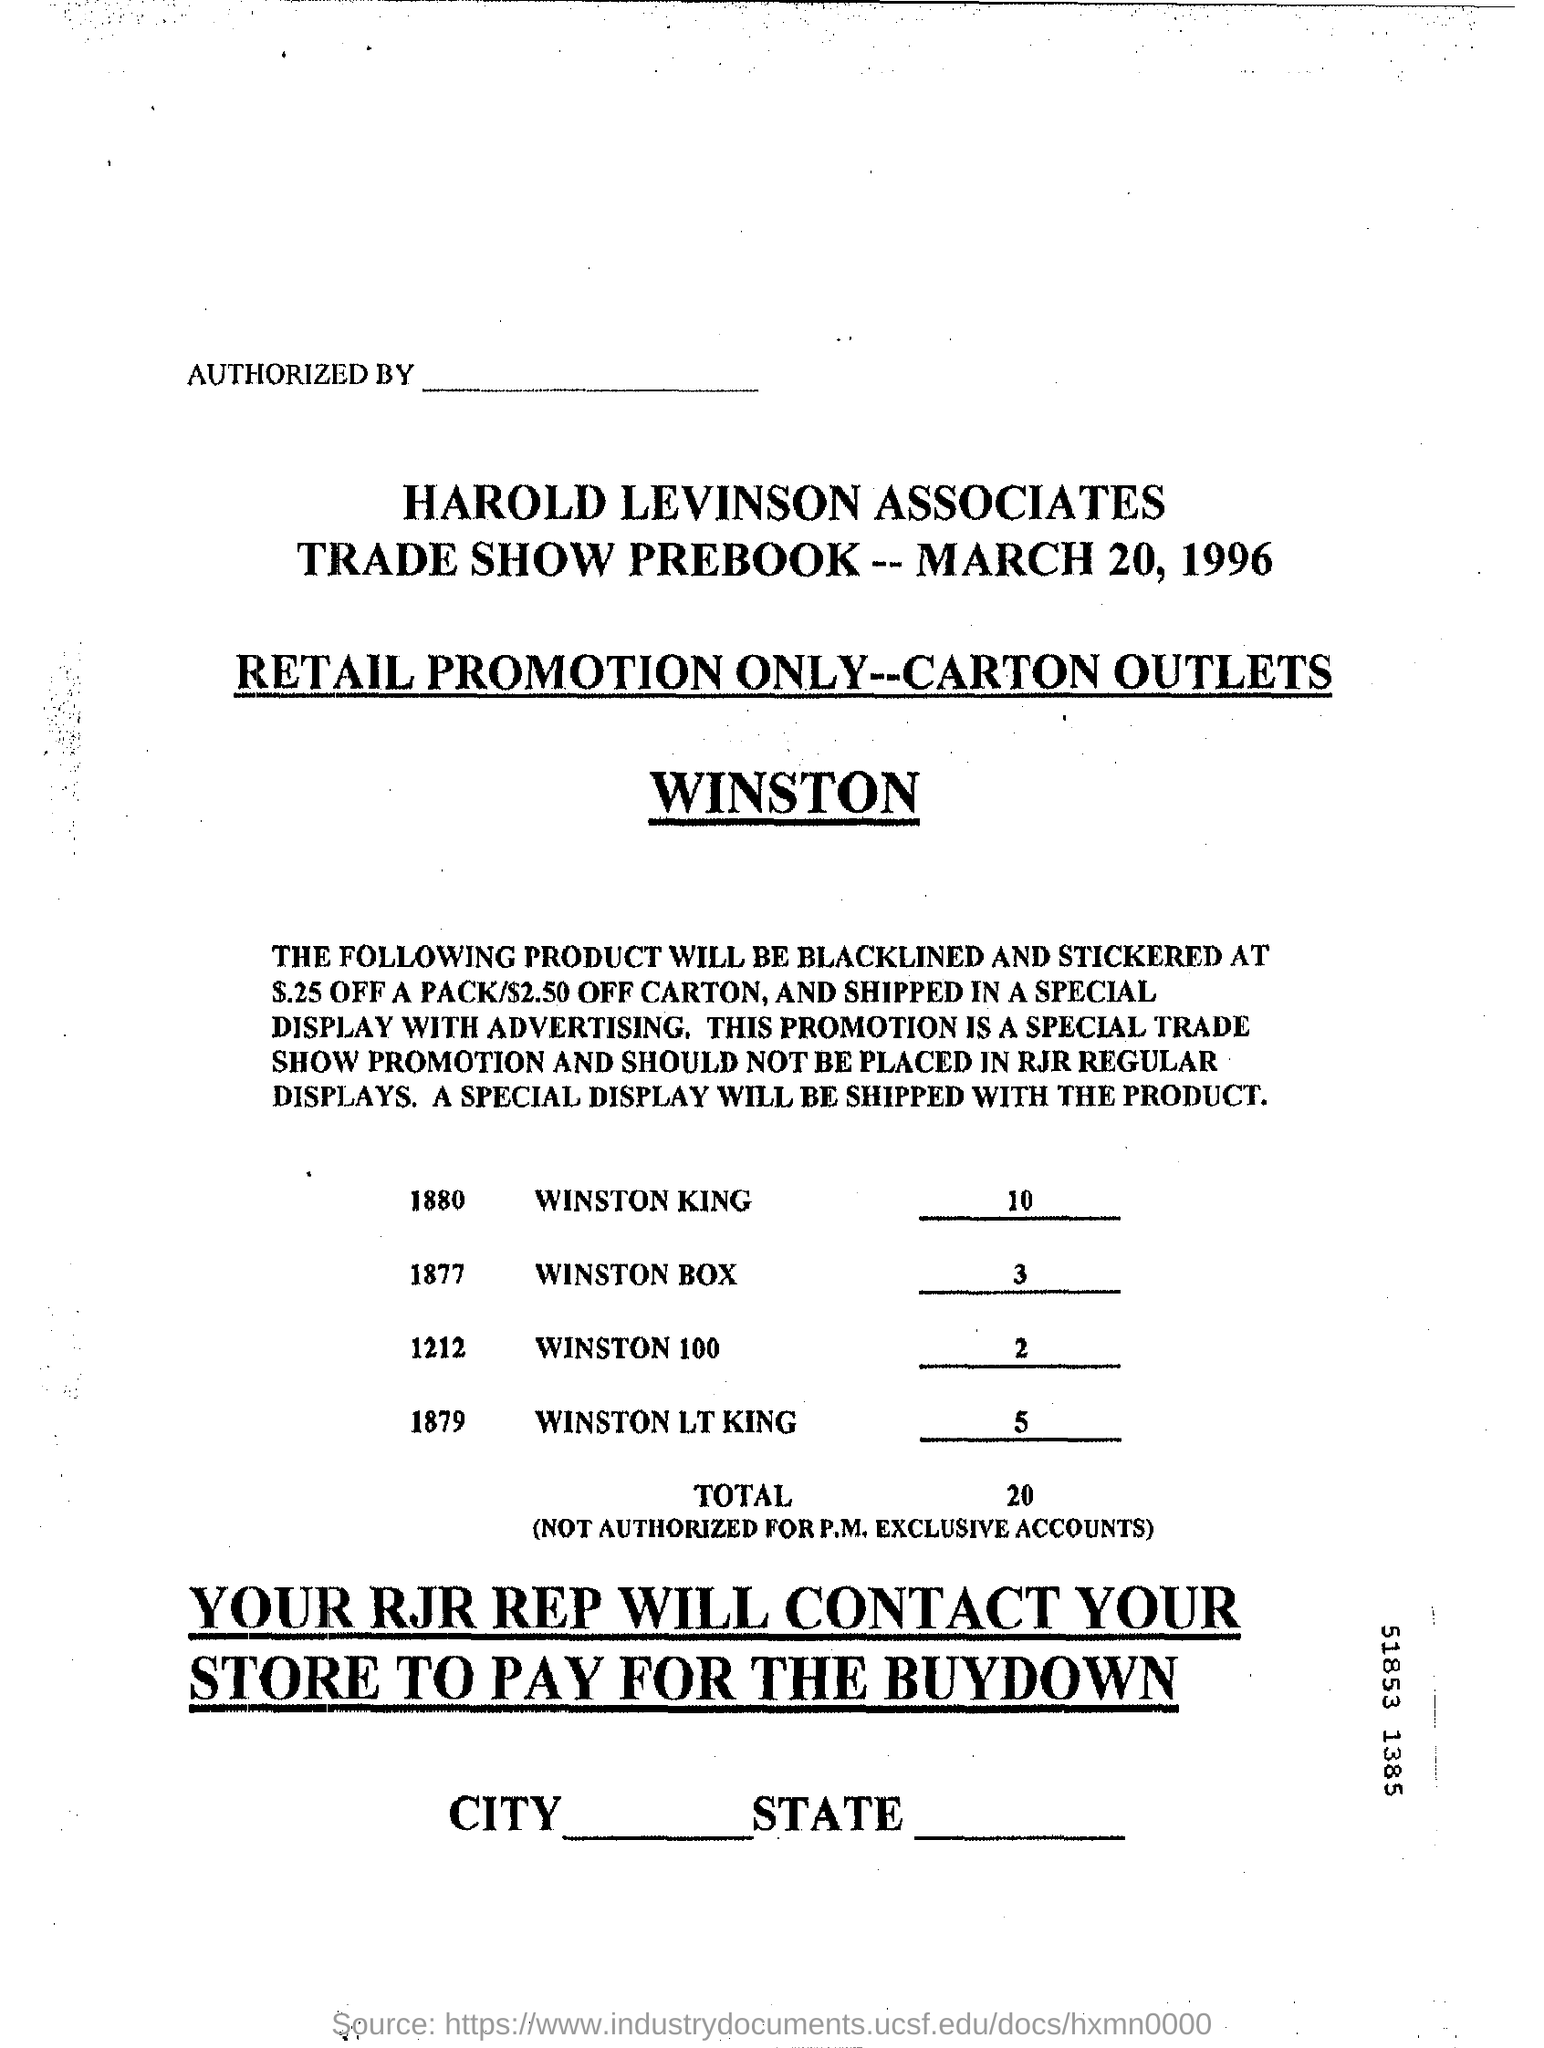What is the date on the document?
Your answer should be very brief. March 20, 1996. 